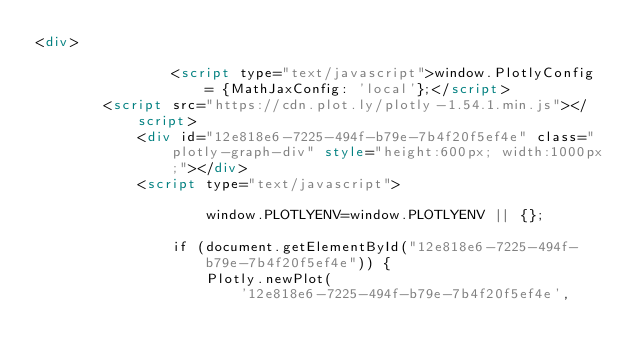Convert code to text. <code><loc_0><loc_0><loc_500><loc_500><_HTML_><div>
        
                <script type="text/javascript">window.PlotlyConfig = {MathJaxConfig: 'local'};</script>
        <script src="https://cdn.plot.ly/plotly-1.54.1.min.js"></script>    
            <div id="12e818e6-7225-494f-b79e-7b4f20f5ef4e" class="plotly-graph-div" style="height:600px; width:1000px;"></div>
            <script type="text/javascript">
                
                    window.PLOTLYENV=window.PLOTLYENV || {};
                    
                if (document.getElementById("12e818e6-7225-494f-b79e-7b4f20f5ef4e")) {
                    Plotly.newPlot(
                        '12e818e6-7225-494f-b79e-7b4f20f5ef4e',</code> 